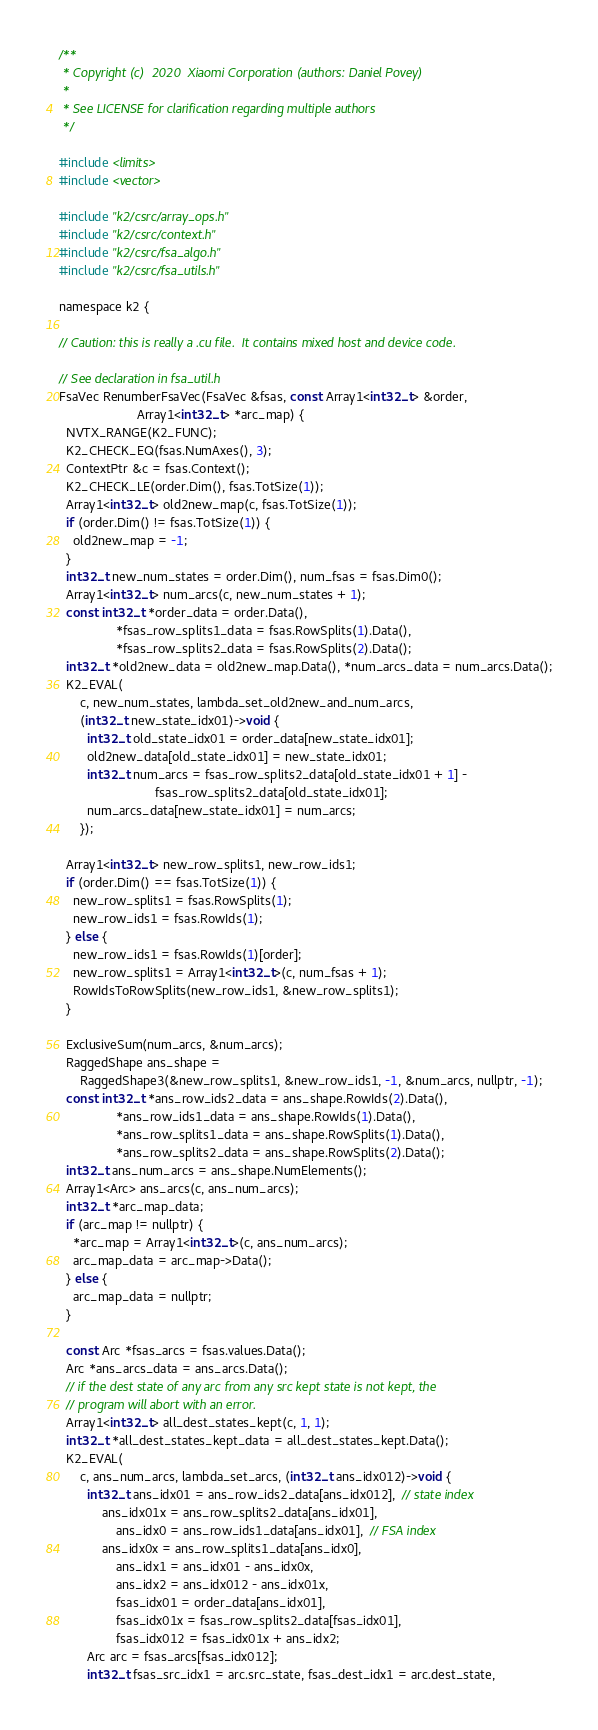Convert code to text. <code><loc_0><loc_0><loc_500><loc_500><_Cuda_>/**
 * Copyright (c)  2020  Xiaomi Corporation (authors: Daniel Povey)
 *
 * See LICENSE for clarification regarding multiple authors
 */

#include <limits>
#include <vector>

#include "k2/csrc/array_ops.h"
#include "k2/csrc/context.h"
#include "k2/csrc/fsa_algo.h"
#include "k2/csrc/fsa_utils.h"

namespace k2 {

// Caution: this is really a .cu file.  It contains mixed host and device code.

// See declaration in fsa_util.h
FsaVec RenumberFsaVec(FsaVec &fsas, const Array1<int32_t> &order,
                      Array1<int32_t> *arc_map) {
  NVTX_RANGE(K2_FUNC);
  K2_CHECK_EQ(fsas.NumAxes(), 3);
  ContextPtr &c = fsas.Context();
  K2_CHECK_LE(order.Dim(), fsas.TotSize(1));
  Array1<int32_t> old2new_map(c, fsas.TotSize(1));
  if (order.Dim() != fsas.TotSize(1)) {
    old2new_map = -1;
  }
  int32_t new_num_states = order.Dim(), num_fsas = fsas.Dim0();
  Array1<int32_t> num_arcs(c, new_num_states + 1);
  const int32_t *order_data = order.Data(),
                *fsas_row_splits1_data = fsas.RowSplits(1).Data(),
                *fsas_row_splits2_data = fsas.RowSplits(2).Data();
  int32_t *old2new_data = old2new_map.Data(), *num_arcs_data = num_arcs.Data();
  K2_EVAL(
      c, new_num_states, lambda_set_old2new_and_num_arcs,
      (int32_t new_state_idx01)->void {
        int32_t old_state_idx01 = order_data[new_state_idx01];
        old2new_data[old_state_idx01] = new_state_idx01;
        int32_t num_arcs = fsas_row_splits2_data[old_state_idx01 + 1] -
                           fsas_row_splits2_data[old_state_idx01];
        num_arcs_data[new_state_idx01] = num_arcs;
      });

  Array1<int32_t> new_row_splits1, new_row_ids1;
  if (order.Dim() == fsas.TotSize(1)) {
    new_row_splits1 = fsas.RowSplits(1);
    new_row_ids1 = fsas.RowIds(1);
  } else {
    new_row_ids1 = fsas.RowIds(1)[order];
    new_row_splits1 = Array1<int32_t>(c, num_fsas + 1);
    RowIdsToRowSplits(new_row_ids1, &new_row_splits1);
  }

  ExclusiveSum(num_arcs, &num_arcs);
  RaggedShape ans_shape =
      RaggedShape3(&new_row_splits1, &new_row_ids1, -1, &num_arcs, nullptr, -1);
  const int32_t *ans_row_ids2_data = ans_shape.RowIds(2).Data(),
                *ans_row_ids1_data = ans_shape.RowIds(1).Data(),
                *ans_row_splits1_data = ans_shape.RowSplits(1).Data(),
                *ans_row_splits2_data = ans_shape.RowSplits(2).Data();
  int32_t ans_num_arcs = ans_shape.NumElements();
  Array1<Arc> ans_arcs(c, ans_num_arcs);
  int32_t *arc_map_data;
  if (arc_map != nullptr) {
    *arc_map = Array1<int32_t>(c, ans_num_arcs);
    arc_map_data = arc_map->Data();
  } else {
    arc_map_data = nullptr;
  }

  const Arc *fsas_arcs = fsas.values.Data();
  Arc *ans_arcs_data = ans_arcs.Data();
  // if the dest state of any arc from any src kept state is not kept, the
  // program will abort with an error.
  Array1<int32_t> all_dest_states_kept(c, 1, 1);
  int32_t *all_dest_states_kept_data = all_dest_states_kept.Data();
  K2_EVAL(
      c, ans_num_arcs, lambda_set_arcs, (int32_t ans_idx012)->void {
        int32_t ans_idx01 = ans_row_ids2_data[ans_idx012],  // state index
            ans_idx01x = ans_row_splits2_data[ans_idx01],
                ans_idx0 = ans_row_ids1_data[ans_idx01],  // FSA index
            ans_idx0x = ans_row_splits1_data[ans_idx0],
                ans_idx1 = ans_idx01 - ans_idx0x,
                ans_idx2 = ans_idx012 - ans_idx01x,
                fsas_idx01 = order_data[ans_idx01],
                fsas_idx01x = fsas_row_splits2_data[fsas_idx01],
                fsas_idx012 = fsas_idx01x + ans_idx2;
        Arc arc = fsas_arcs[fsas_idx012];
        int32_t fsas_src_idx1 = arc.src_state, fsas_dest_idx1 = arc.dest_state,</code> 